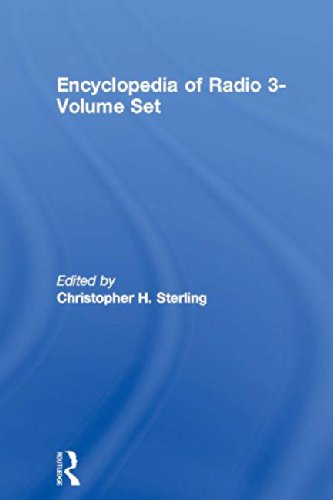What is the genre of this book? The genre of the book is primarily 'Reference' given its detailed and scholarly content on the comprehensive subject of radio communication technology and its history. 